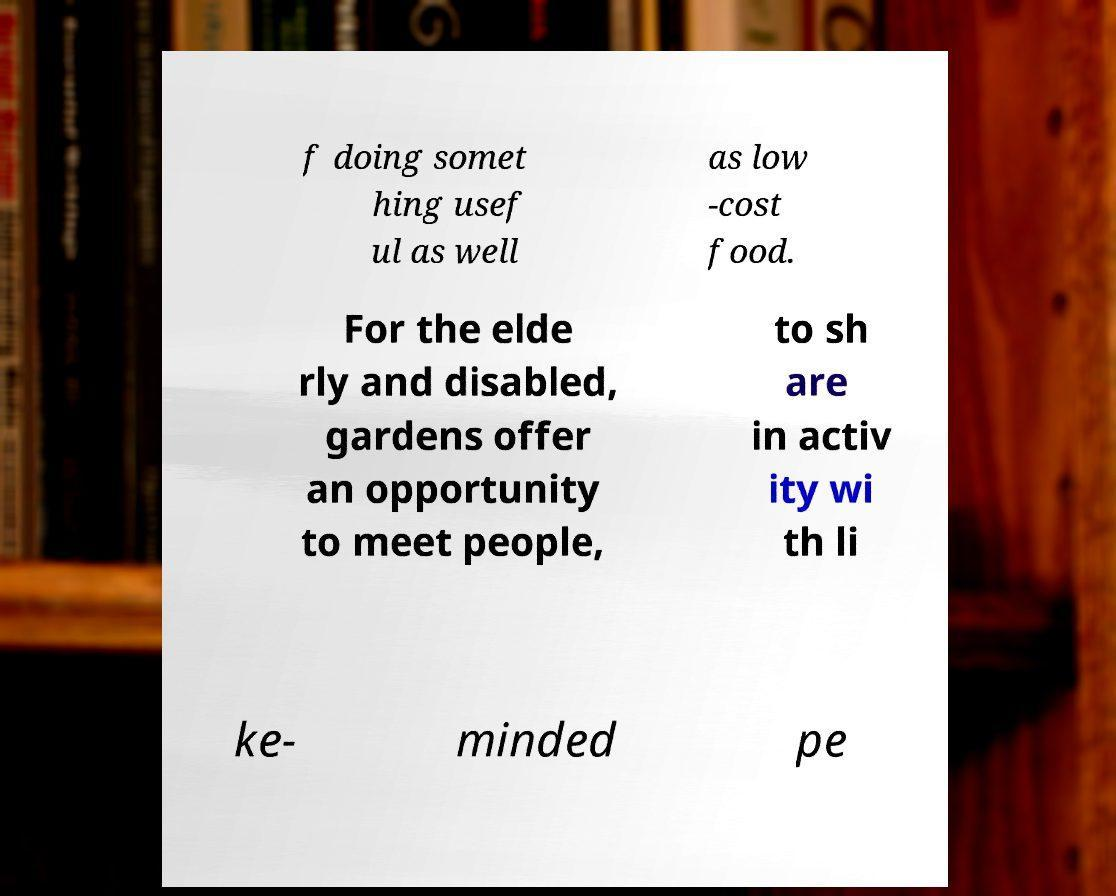Please read and relay the text visible in this image. What does it say? f doing somet hing usef ul as well as low -cost food. For the elde rly and disabled, gardens offer an opportunity to meet people, to sh are in activ ity wi th li ke- minded pe 